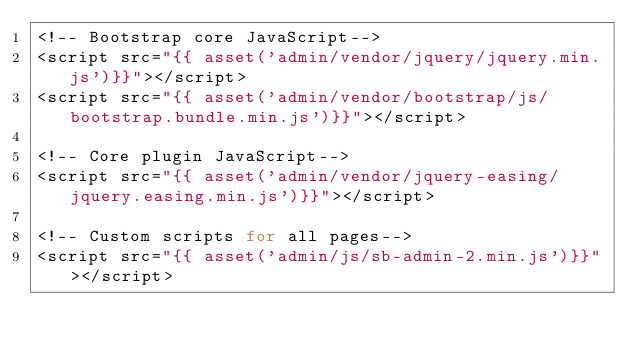<code> <loc_0><loc_0><loc_500><loc_500><_PHP_><!-- Bootstrap core JavaScript-->
<script src="{{ asset('admin/vendor/jquery/jquery.min.js')}}"></script>
<script src="{{ asset('admin/vendor/bootstrap/js/bootstrap.bundle.min.js')}}"></script>

<!-- Core plugin JavaScript-->
<script src="{{ asset('admin/vendor/jquery-easing/jquery.easing.min.js')}}"></script>

<!-- Custom scripts for all pages-->
<script src="{{ asset('admin/js/sb-admin-2.min.js')}}"></script></code> 